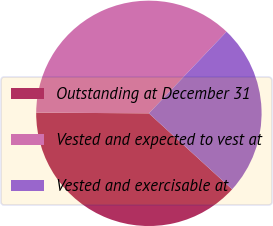Convert chart to OTSL. <chart><loc_0><loc_0><loc_500><loc_500><pie_chart><fcel>Outstanding at December 31<fcel>Vested and expected to vest at<fcel>Vested and exercisable at<nl><fcel>38.33%<fcel>37.0%<fcel>24.67%<nl></chart> 